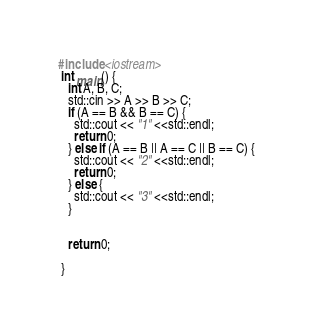Convert code to text. <code><loc_0><loc_0><loc_500><loc_500><_C++_>#include <iostream>
 int main() {
   int A, B, C;
   std::cin >> A >> B >> C;
   if (A == B && B == C) {
     std::cout << "1" <<std::endl;
     return 0;
   } else if (A == B || A == C || B == C) {
     std::cout << "2" <<std::endl;
     return 0;
   } else {
     std::cout << "3" <<std::endl;
   }
   
   
   return 0;
   
 }</code> 